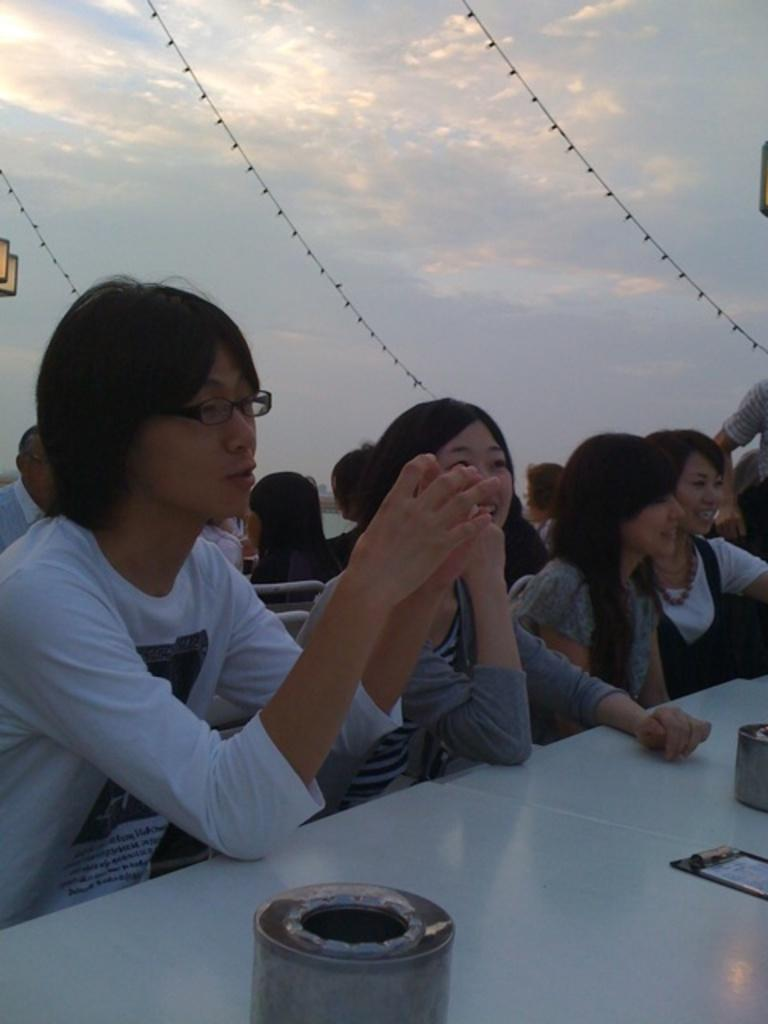What are the people in the image doing? There is a group of people sitting in the image. What can be seen on the table in the image? There are objects on a table in the image. What is visible in the background of the image? The sky is visible in the background of the image. What type of fruit is being discussed by the group of people in the image? There is no fruit present in the image, nor is there any indication of a discussion about fruit. 